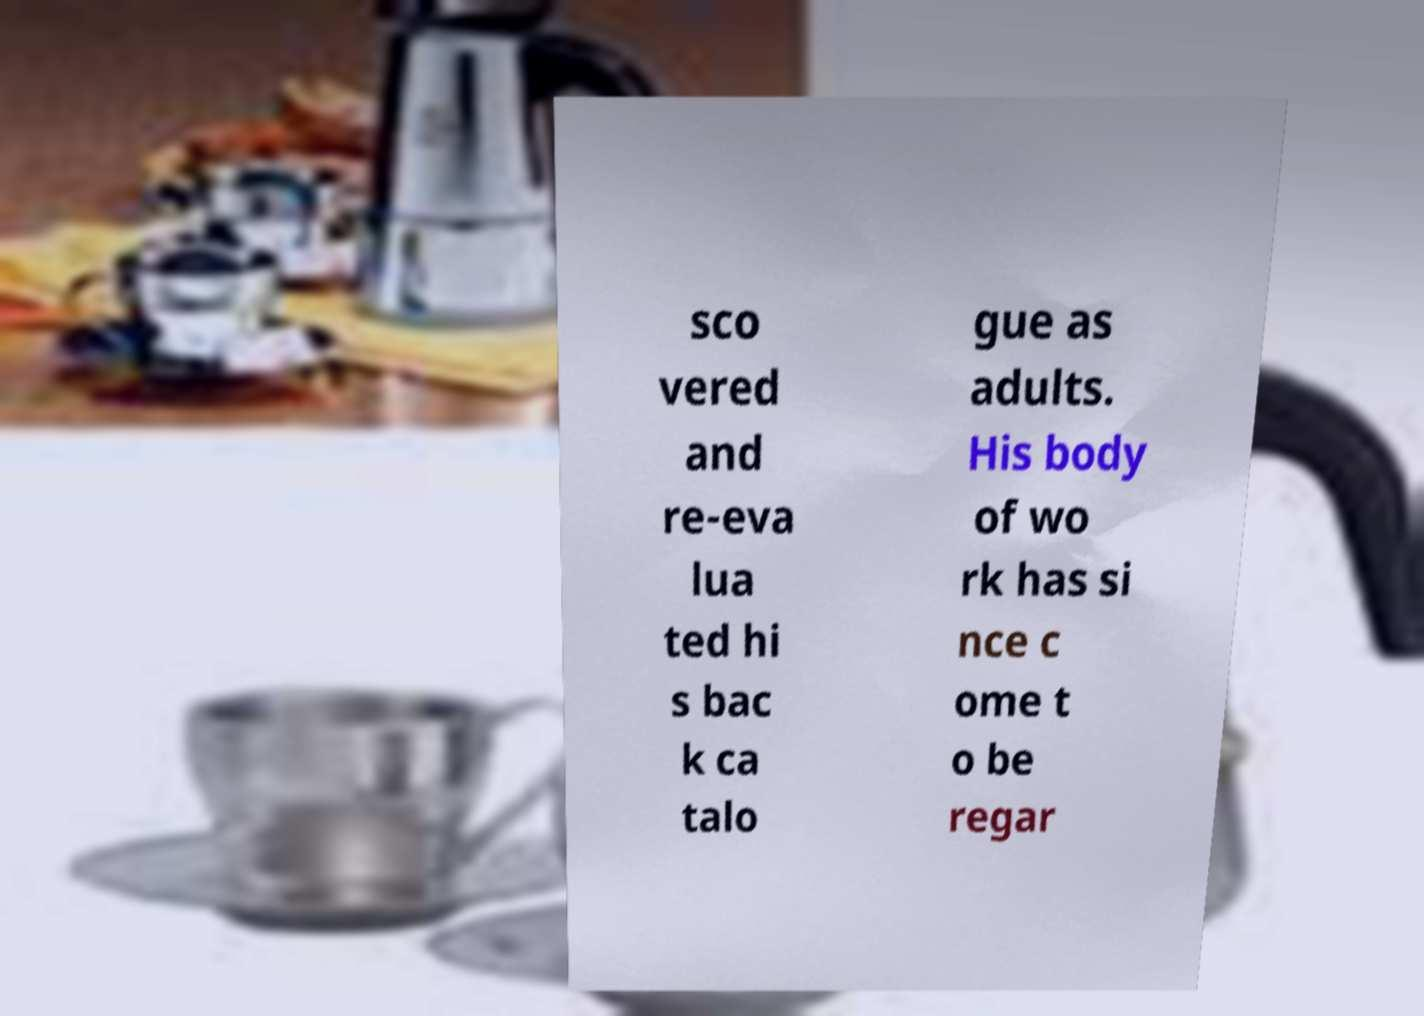Could you assist in decoding the text presented in this image and type it out clearly? sco vered and re-eva lua ted hi s bac k ca talo gue as adults. His body of wo rk has si nce c ome t o be regar 